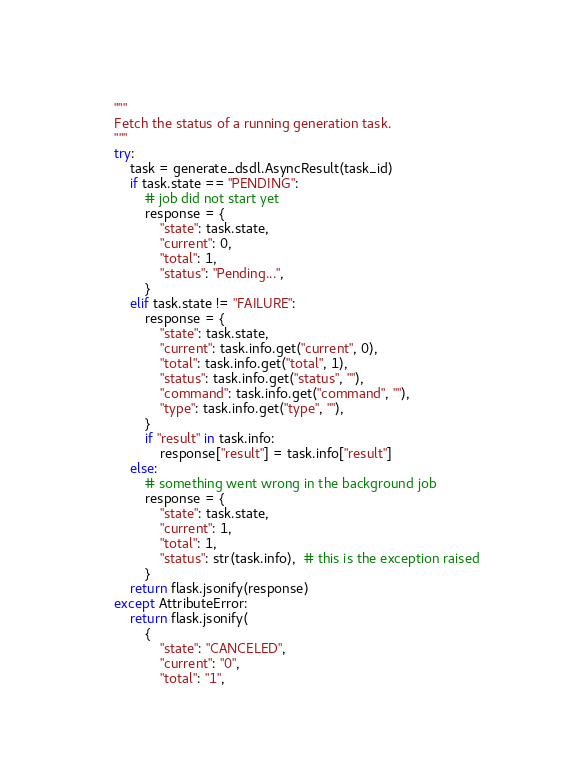Convert code to text. <code><loc_0><loc_0><loc_500><loc_500><_Python_>    """
    Fetch the status of a running generation task.
    """
    try:
        task = generate_dsdl.AsyncResult(task_id)
        if task.state == "PENDING":
            # job did not start yet
            response = {
                "state": task.state,
                "current": 0,
                "total": 1,
                "status": "Pending...",
            }
        elif task.state != "FAILURE":
            response = {
                "state": task.state,
                "current": task.info.get("current", 0),
                "total": task.info.get("total", 1),
                "status": task.info.get("status", ""),
                "command": task.info.get("command", ""),
                "type": task.info.get("type", ""),
            }
            if "result" in task.info:
                response["result"] = task.info["result"]
        else:
            # something went wrong in the background job
            response = {
                "state": task.state,
                "current": 1,
                "total": 1,
                "status": str(task.info),  # this is the exception raised
            }
        return flask.jsonify(response)
    except AttributeError:
        return flask.jsonify(
            {
                "state": "CANCELED",
                "current": "0",
                "total": "1",</code> 